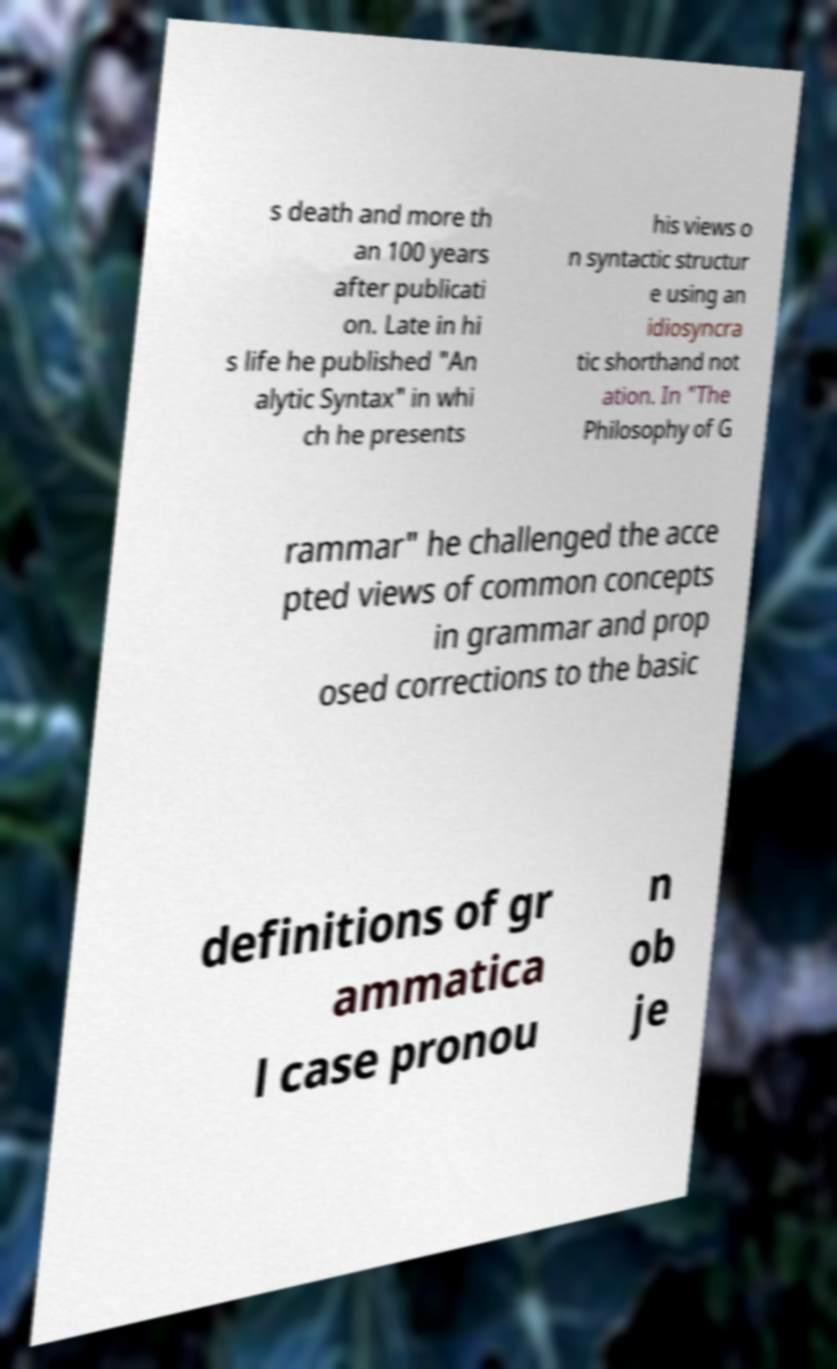Can you read and provide the text displayed in the image?This photo seems to have some interesting text. Can you extract and type it out for me? s death and more th an 100 years after publicati on. Late in hi s life he published "An alytic Syntax" in whi ch he presents his views o n syntactic structur e using an idiosyncra tic shorthand not ation. In "The Philosophy of G rammar" he challenged the acce pted views of common concepts in grammar and prop osed corrections to the basic definitions of gr ammatica l case pronou n ob je 